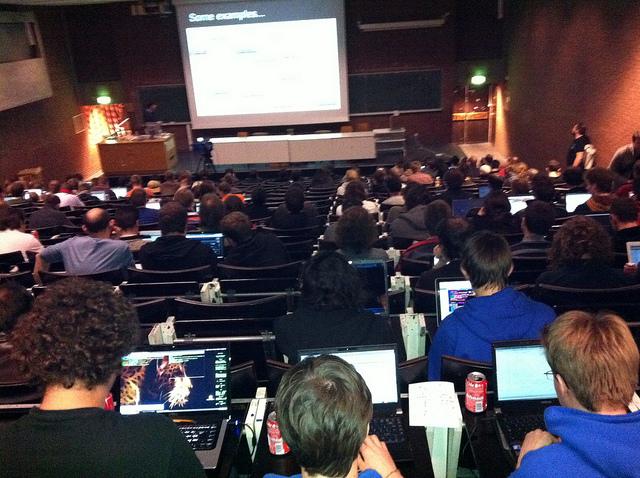How are most of these students taking notes?
Write a very short answer. Computer. Where are the young people at?
Quick response, please. School. Do the students have laptops?
Short answer required. Yes. 